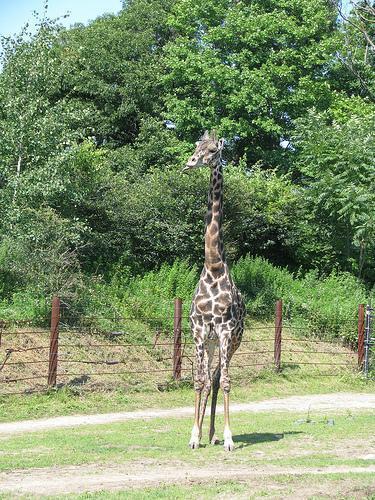How many animals are there?
Give a very brief answer. 1. 